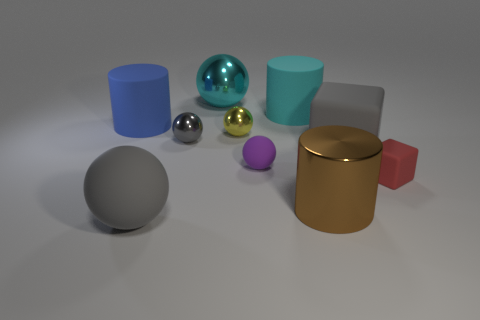There is a large brown thing; are there any large gray objects behind it?
Give a very brief answer. Yes. The sphere that is the same size as the cyan shiny object is what color?
Offer a terse response. Gray. What number of cyan objects have the same material as the brown cylinder?
Your response must be concise. 1. How many other things are the same size as the red matte cube?
Give a very brief answer. 3. Is there a metallic sphere that has the same size as the yellow object?
Give a very brief answer. Yes. Do the ball that is on the left side of the gray shiny sphere and the large rubber cube have the same color?
Make the answer very short. Yes. How many things are blue cylinders or blue metallic cylinders?
Offer a very short reply. 1. There is a gray sphere that is in front of the metal cylinder; is it the same size as the purple rubber sphere?
Offer a terse response. No. There is a metal object that is both on the right side of the large metal ball and left of the brown metal thing; what size is it?
Ensure brevity in your answer.  Small. What number of other objects are the same shape as the blue object?
Your answer should be compact. 2. 